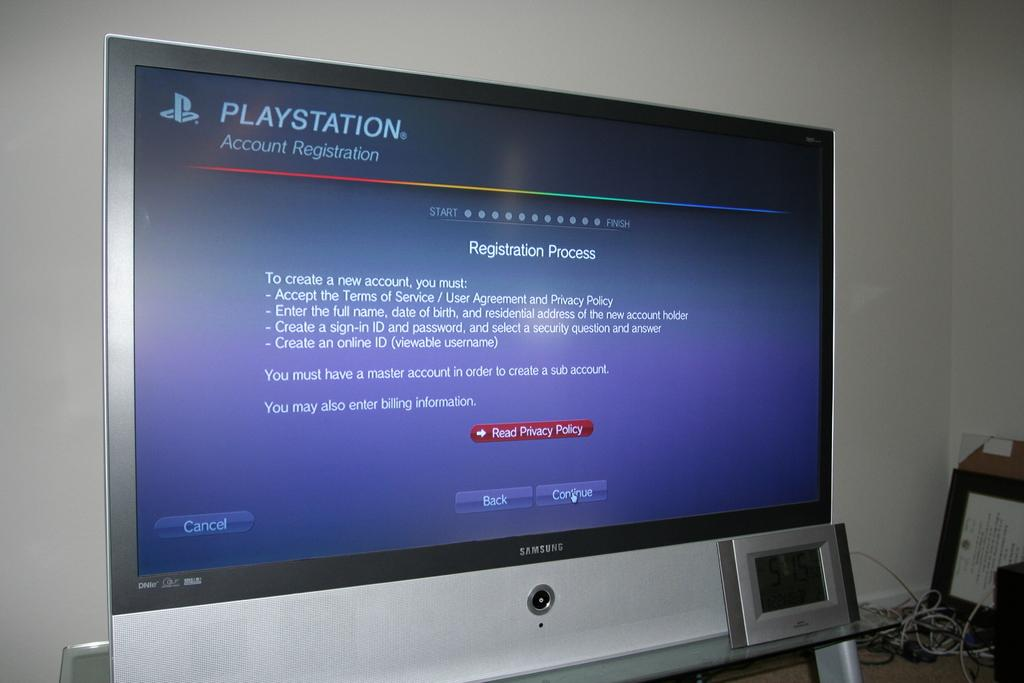<image>
Describe the image concisely. A very large screen with blue background with Playstation registration process on it 